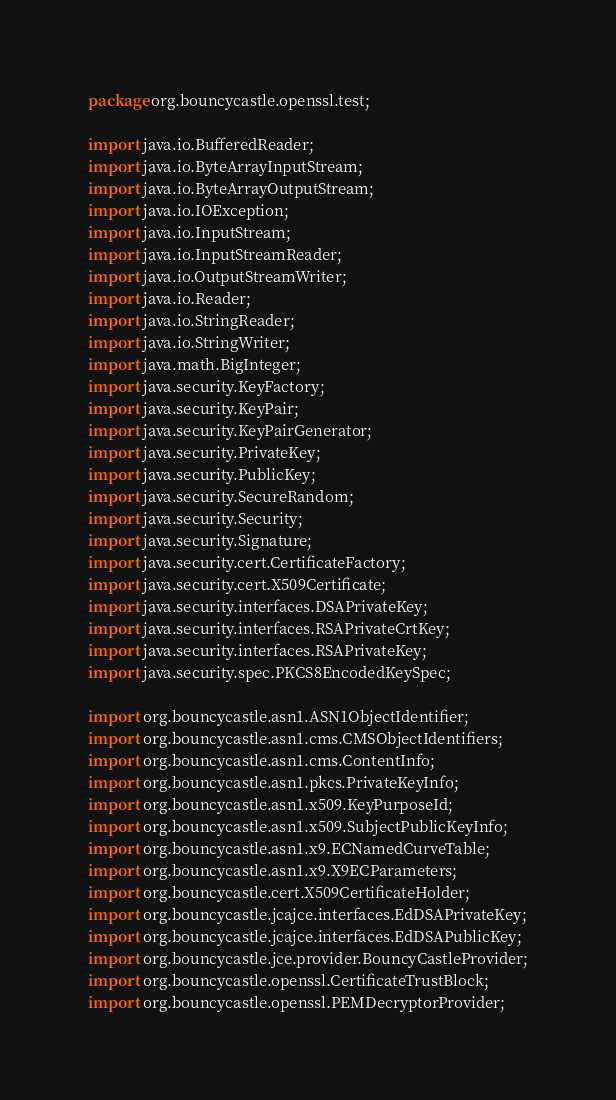<code> <loc_0><loc_0><loc_500><loc_500><_Java_>package org.bouncycastle.openssl.test;

import java.io.BufferedReader;
import java.io.ByteArrayInputStream;
import java.io.ByteArrayOutputStream;
import java.io.IOException;
import java.io.InputStream;
import java.io.InputStreamReader;
import java.io.OutputStreamWriter;
import java.io.Reader;
import java.io.StringReader;
import java.io.StringWriter;
import java.math.BigInteger;
import java.security.KeyFactory;
import java.security.KeyPair;
import java.security.KeyPairGenerator;
import java.security.PrivateKey;
import java.security.PublicKey;
import java.security.SecureRandom;
import java.security.Security;
import java.security.Signature;
import java.security.cert.CertificateFactory;
import java.security.cert.X509Certificate;
import java.security.interfaces.DSAPrivateKey;
import java.security.interfaces.RSAPrivateCrtKey;
import java.security.interfaces.RSAPrivateKey;
import java.security.spec.PKCS8EncodedKeySpec;

import org.bouncycastle.asn1.ASN1ObjectIdentifier;
import org.bouncycastle.asn1.cms.CMSObjectIdentifiers;
import org.bouncycastle.asn1.cms.ContentInfo;
import org.bouncycastle.asn1.pkcs.PrivateKeyInfo;
import org.bouncycastle.asn1.x509.KeyPurposeId;
import org.bouncycastle.asn1.x509.SubjectPublicKeyInfo;
import org.bouncycastle.asn1.x9.ECNamedCurveTable;
import org.bouncycastle.asn1.x9.X9ECParameters;
import org.bouncycastle.cert.X509CertificateHolder;
import org.bouncycastle.jcajce.interfaces.EdDSAPrivateKey;
import org.bouncycastle.jcajce.interfaces.EdDSAPublicKey;
import org.bouncycastle.jce.provider.BouncyCastleProvider;
import org.bouncycastle.openssl.CertificateTrustBlock;
import org.bouncycastle.openssl.PEMDecryptorProvider;</code> 